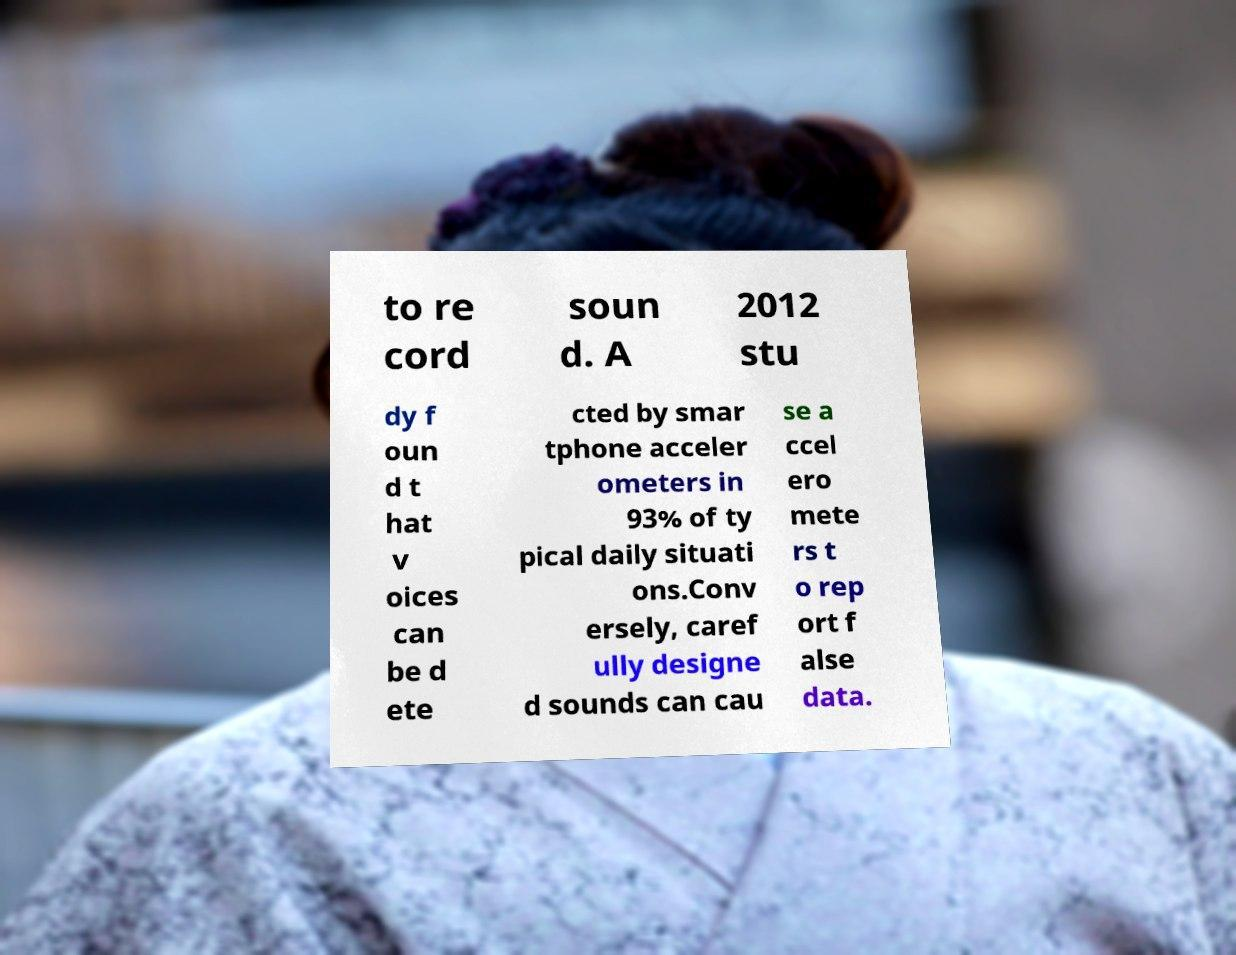I need the written content from this picture converted into text. Can you do that? to re cord soun d. A 2012 stu dy f oun d t hat v oices can be d ete cted by smar tphone acceler ometers in 93% of ty pical daily situati ons.Conv ersely, caref ully designe d sounds can cau se a ccel ero mete rs t o rep ort f alse data. 